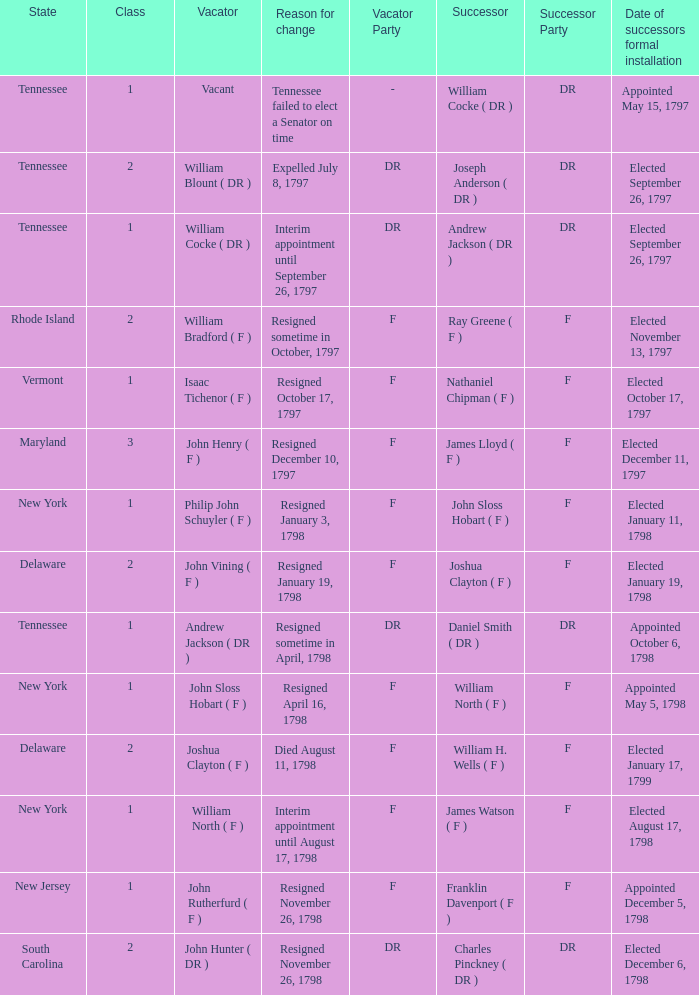What are all the states (class) when the successor was Joseph Anderson ( DR )? Tennessee (2). 